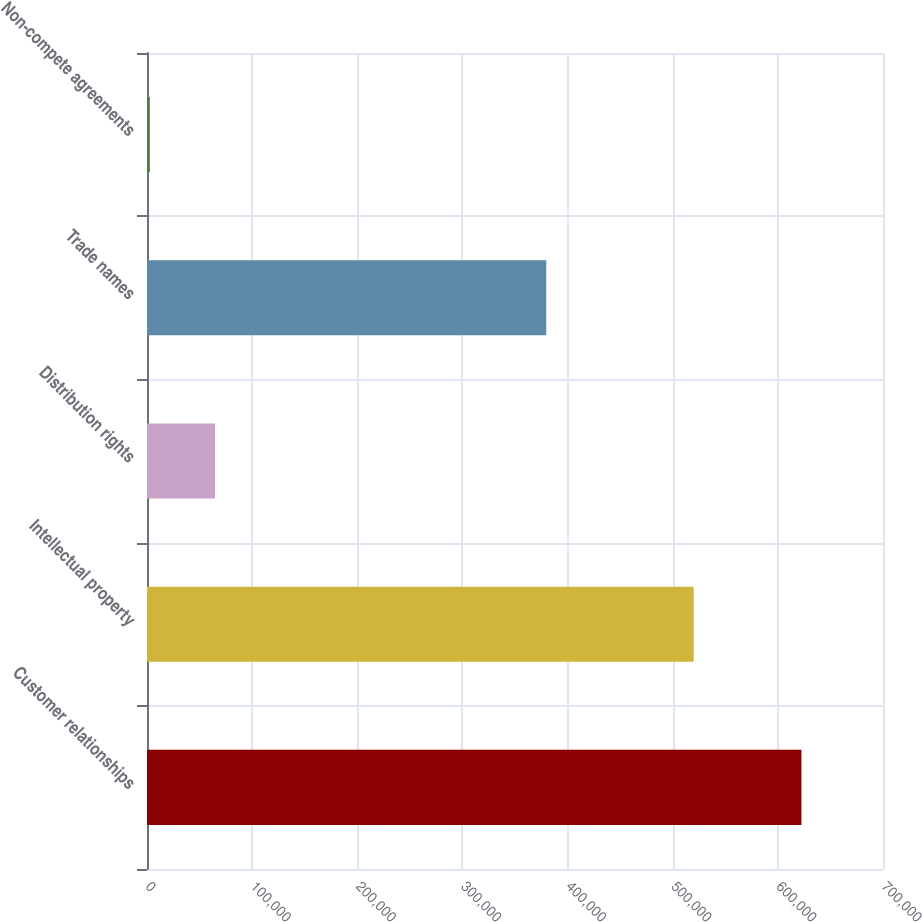<chart> <loc_0><loc_0><loc_500><loc_500><bar_chart><fcel>Customer relationships<fcel>Intellectual property<fcel>Distribution rights<fcel>Trade names<fcel>Non-compete agreements<nl><fcel>622428<fcel>519962<fcel>64665.6<fcel>379724<fcel>2692<nl></chart> 